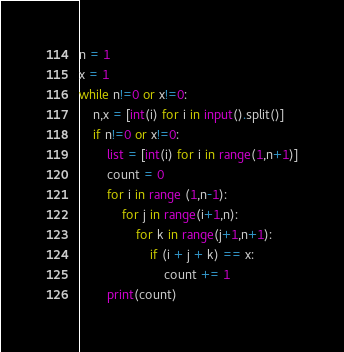<code> <loc_0><loc_0><loc_500><loc_500><_Python_>n = 1
x = 1
while n!=0 or x!=0:
	n,x = [int(i) for i in input().split()]
	if n!=0 or x!=0:
		list = [int(i) for i in range(1,n+1)]
		count = 0
		for i in range (1,n-1):
			for j in range(i+1,n):
				for k in range(j+1,n+1):
					if (i + j + k) == x:
						count += 1
		print(count)</code> 